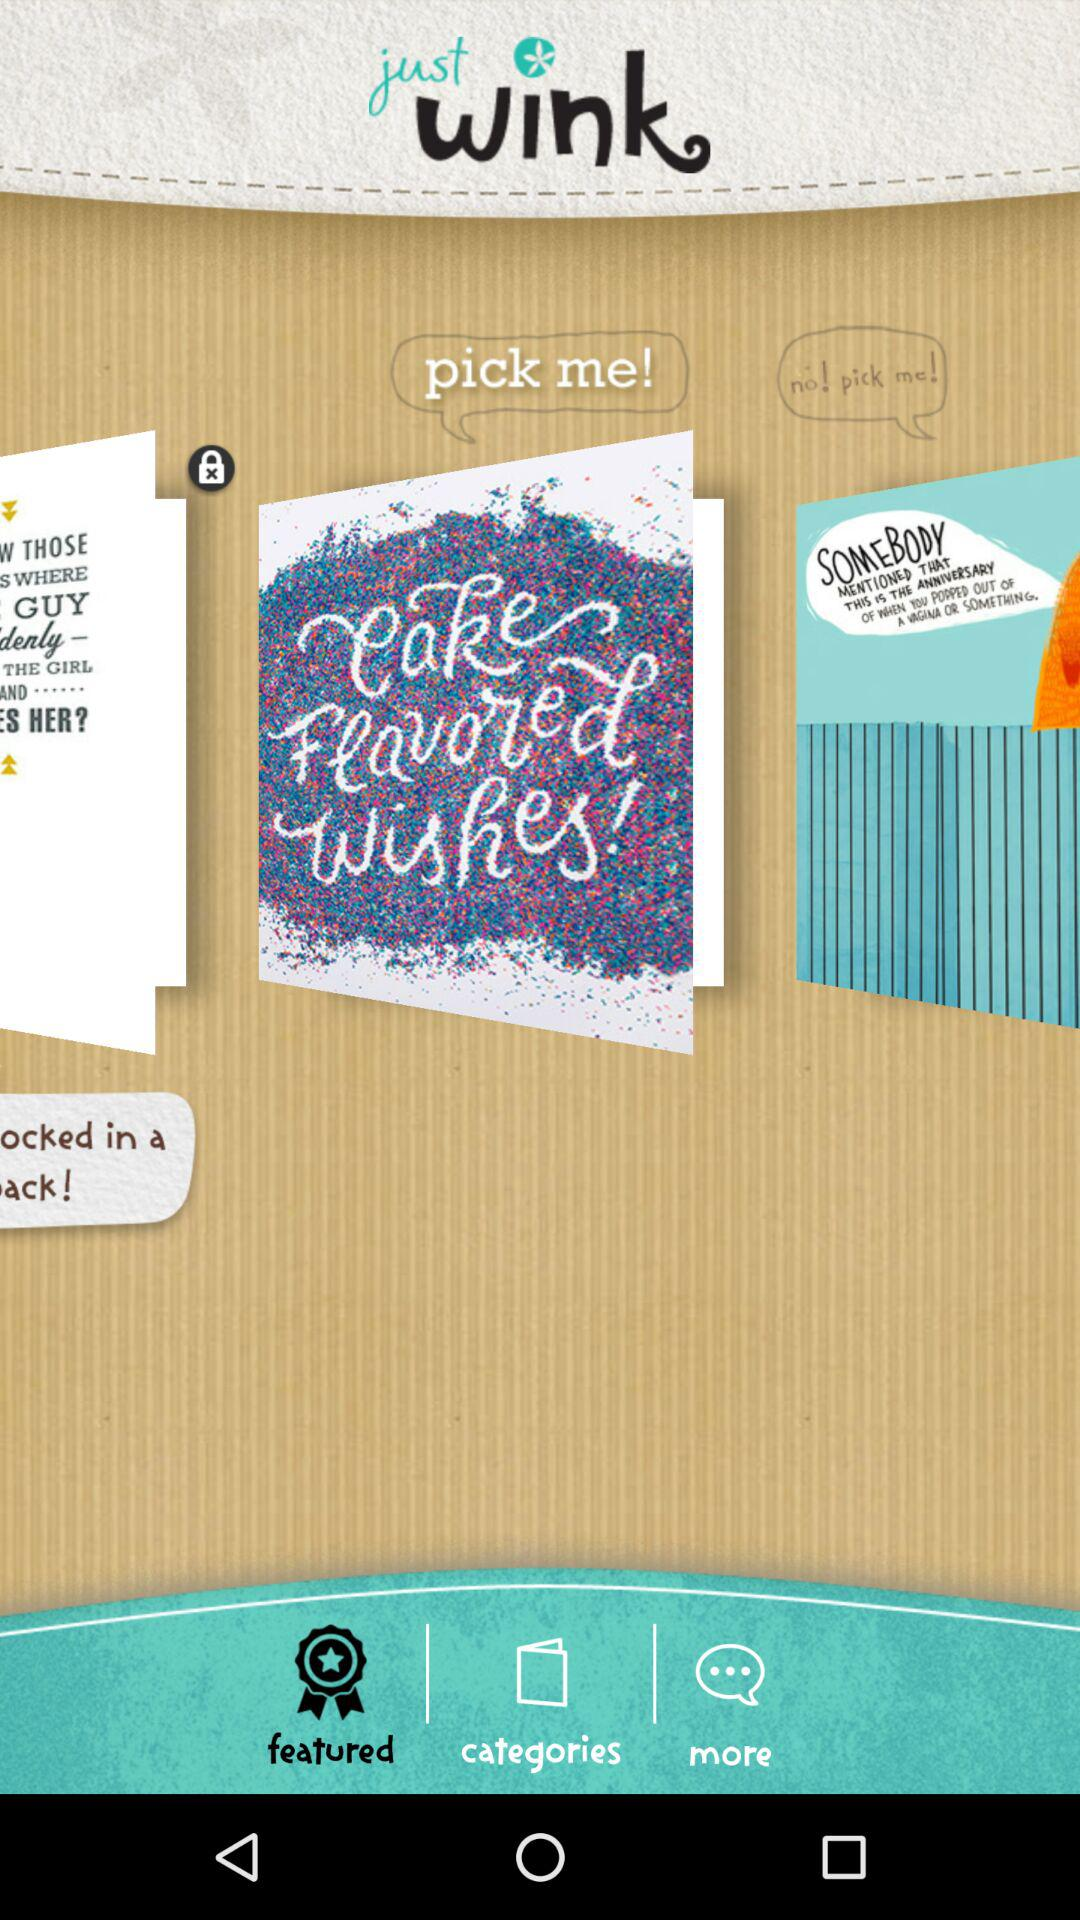Which tab is selected? The selected tab is "featured". 